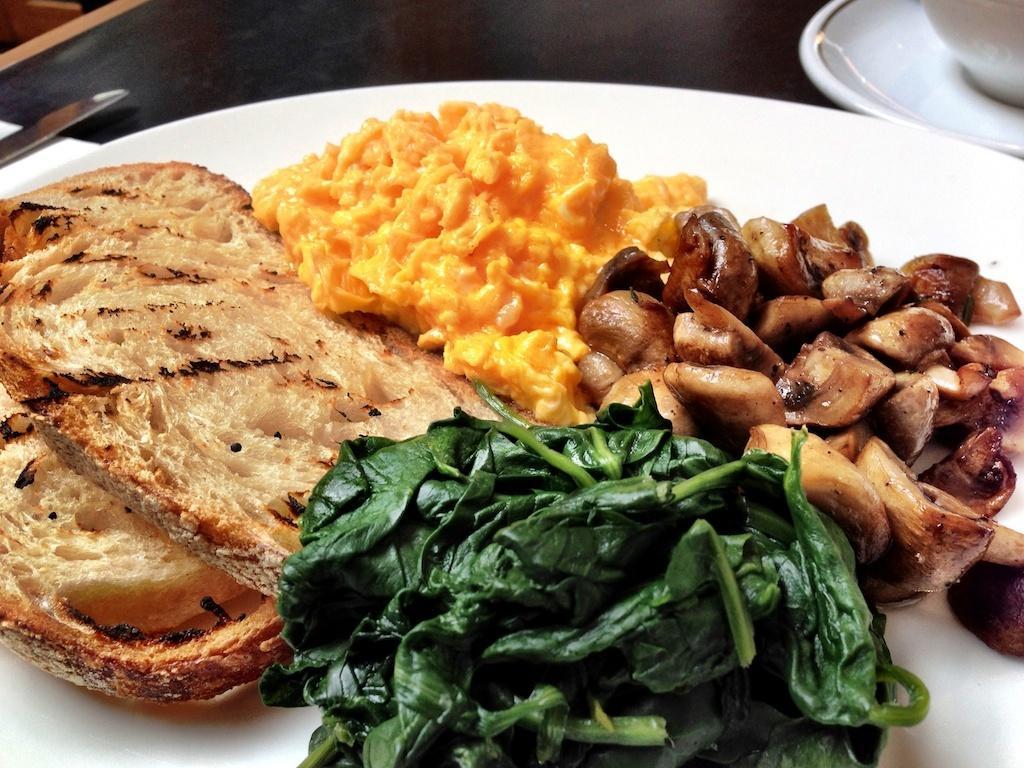How would you summarize this image in a sentence or two? In this picture we can see a white plate with food items on it, knife, cup and saucer and these all are placed on a table. 